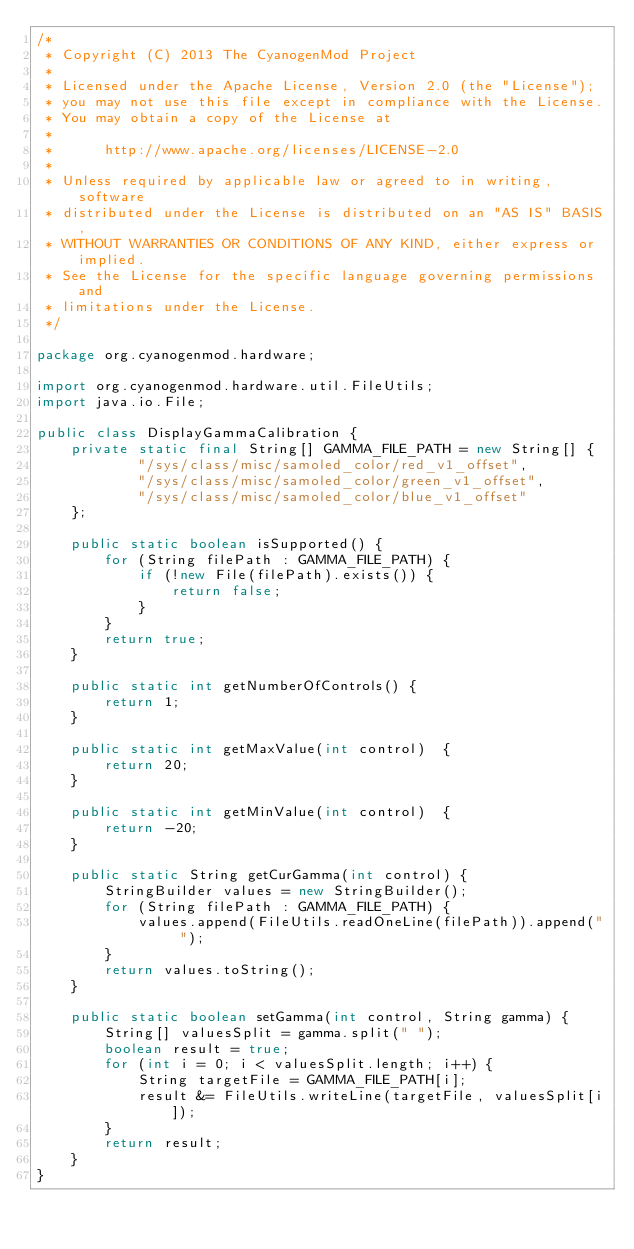Convert code to text. <code><loc_0><loc_0><loc_500><loc_500><_Java_>/*
 * Copyright (C) 2013 The CyanogenMod Project
 *
 * Licensed under the Apache License, Version 2.0 (the "License");
 * you may not use this file except in compliance with the License.
 * You may obtain a copy of the License at
 *
 *      http://www.apache.org/licenses/LICENSE-2.0
 *
 * Unless required by applicable law or agreed to in writing, software
 * distributed under the License is distributed on an "AS IS" BASIS,
 * WITHOUT WARRANTIES OR CONDITIONS OF ANY KIND, either express or implied.
 * See the License for the specific language governing permissions and
 * limitations under the License.
 */

package org.cyanogenmod.hardware;

import org.cyanogenmod.hardware.util.FileUtils;
import java.io.File;

public class DisplayGammaCalibration {
    private static final String[] GAMMA_FILE_PATH = new String[] {
            "/sys/class/misc/samoled_color/red_v1_offset",
            "/sys/class/misc/samoled_color/green_v1_offset",
            "/sys/class/misc/samoled_color/blue_v1_offset"
    };

    public static boolean isSupported() {
        for (String filePath : GAMMA_FILE_PATH) {
            if (!new File(filePath).exists()) {
                return false;
            }
        }
        return true;
    }

    public static int getNumberOfControls() {
        return 1;
    }

    public static int getMaxValue(int control)  {
        return 20;
    }

    public static int getMinValue(int control)  {
        return -20;
    }

    public static String getCurGamma(int control) {
        StringBuilder values = new StringBuilder();
        for (String filePath : GAMMA_FILE_PATH) {
            values.append(FileUtils.readOneLine(filePath)).append(" ");
        }
        return values.toString();
    }

    public static boolean setGamma(int control, String gamma) {
        String[] valuesSplit = gamma.split(" ");
        boolean result = true;
        for (int i = 0; i < valuesSplit.length; i++) {
            String targetFile = GAMMA_FILE_PATH[i];
            result &= FileUtils.writeLine(targetFile, valuesSplit[i]);
        }
        return result;
    }
}
</code> 